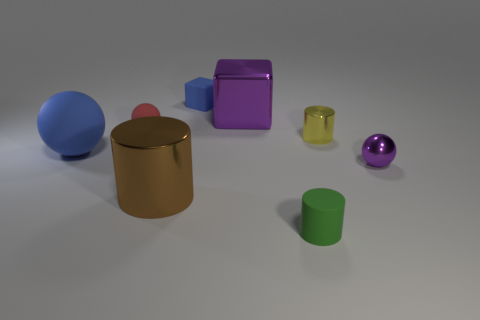There is a tiny object that is the same color as the big matte thing; what material is it?
Keep it short and to the point. Rubber. What color is the small ball that is the same material as the big brown cylinder?
Provide a short and direct response. Purple. What is the material of the large brown object that is the same shape as the tiny yellow object?
Give a very brief answer. Metal. What is the shape of the yellow thing?
Give a very brief answer. Cylinder. There is a cylinder that is behind the green rubber object and to the left of the yellow metal cylinder; what is its material?
Your answer should be compact. Metal. What shape is the big brown thing that is made of the same material as the tiny yellow object?
Give a very brief answer. Cylinder. The cylinder that is made of the same material as the tiny red object is what size?
Provide a short and direct response. Small. What is the shape of the thing that is behind the small yellow cylinder and to the right of the small blue thing?
Keep it short and to the point. Cube. There is a green rubber object that is on the right side of the blue rubber thing on the right side of the red object; what size is it?
Offer a very short reply. Small. How many other things are the same color as the large rubber thing?
Ensure brevity in your answer.  1. 